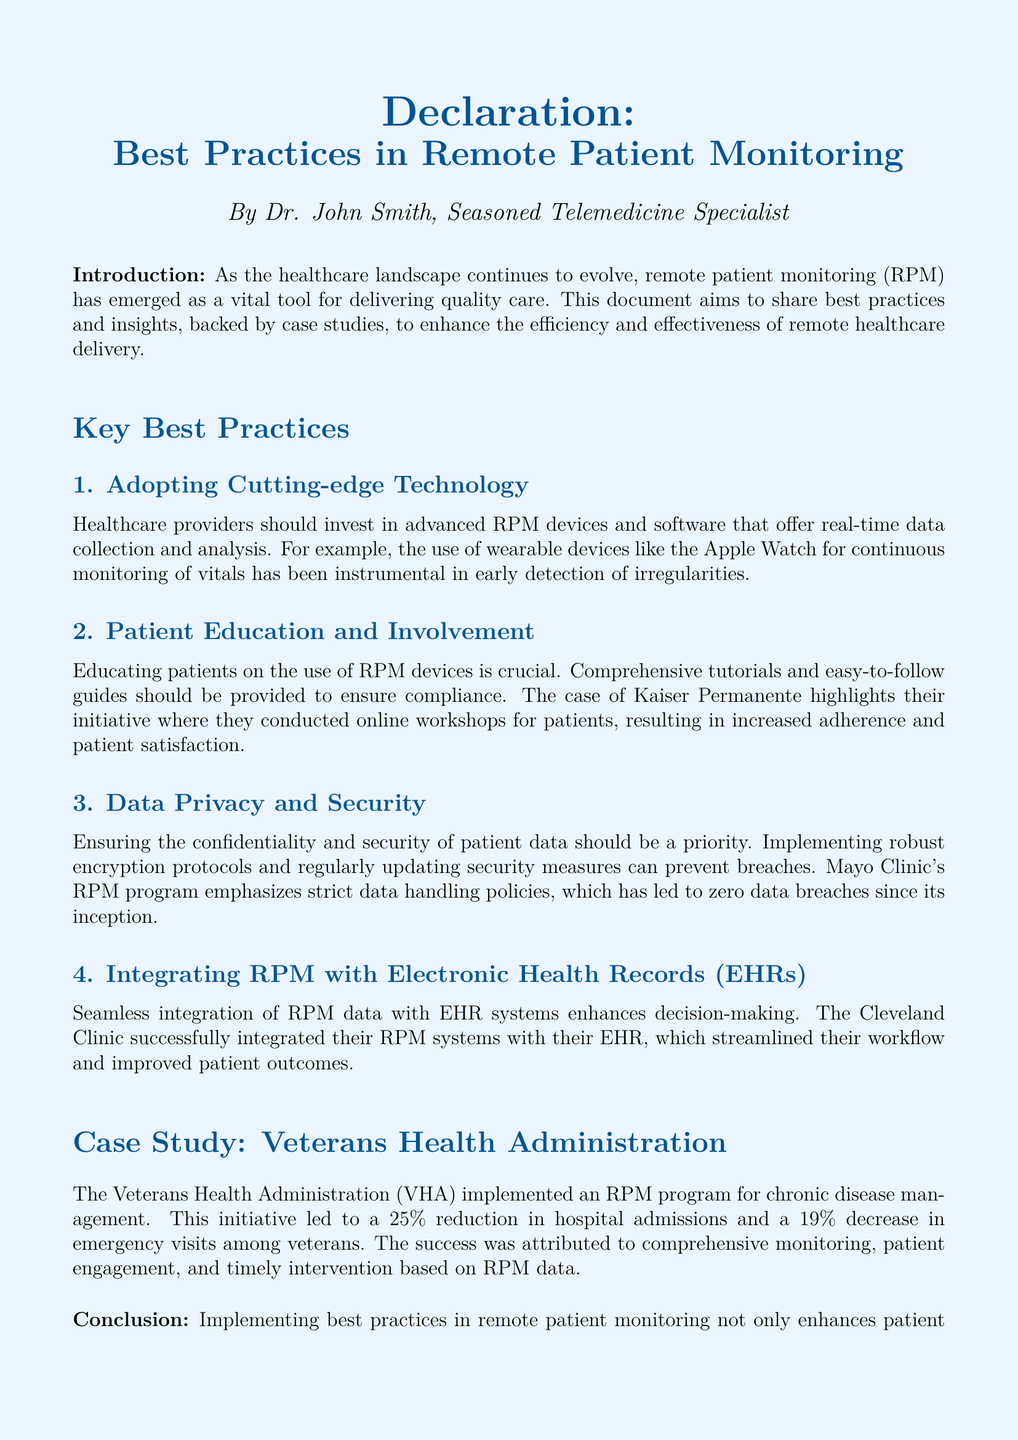what is the title of the document? The title of the document is the heading displayed at the top, which describes the focus of the content.
Answer: Best Practices in Remote Patient Monitoring who authored the document? The author is indicated in the introduction section, stating who is responsible for the content.
Answer: Dr. John Smith what percentage reduction in hospital admissions did the Veterans Health Administration achieve? The document cites a specific percentage related to hospital admission reductions in a case study.
Answer: 25% what is one example of a cutting-edge technology mentioned? The document provides specific examples of technologies used in RPM.
Answer: Apple Watch what is emphasized as crucial for patient compliance? The document discusses the importance of a certain aspect related to patient involvement in using RPM devices.
Answer: Patient Education what organization is highlighted for conducting online workshops for patients? This organization is mentioned in the context of their efforts to improve patient satisfaction through education.
Answer: Kaiser Permanente what has been the outcome of Mayo Clinic's RPM program in terms of data breaches? The document provides an outcome related to data security, specifically addressing breaches.
Answer: Zero data breaches how does the Cleveland Clinic enhance decision-making within their RPM systems? The document describes how they integrate information to improve a certain process in healthcare.
Answer: Integrating RPM with EHRs what was the percentage decrease in emergency visits reported by the VHA? The document cites another specific percentage related to emergency visit reductions in the case study.
Answer: 19% 